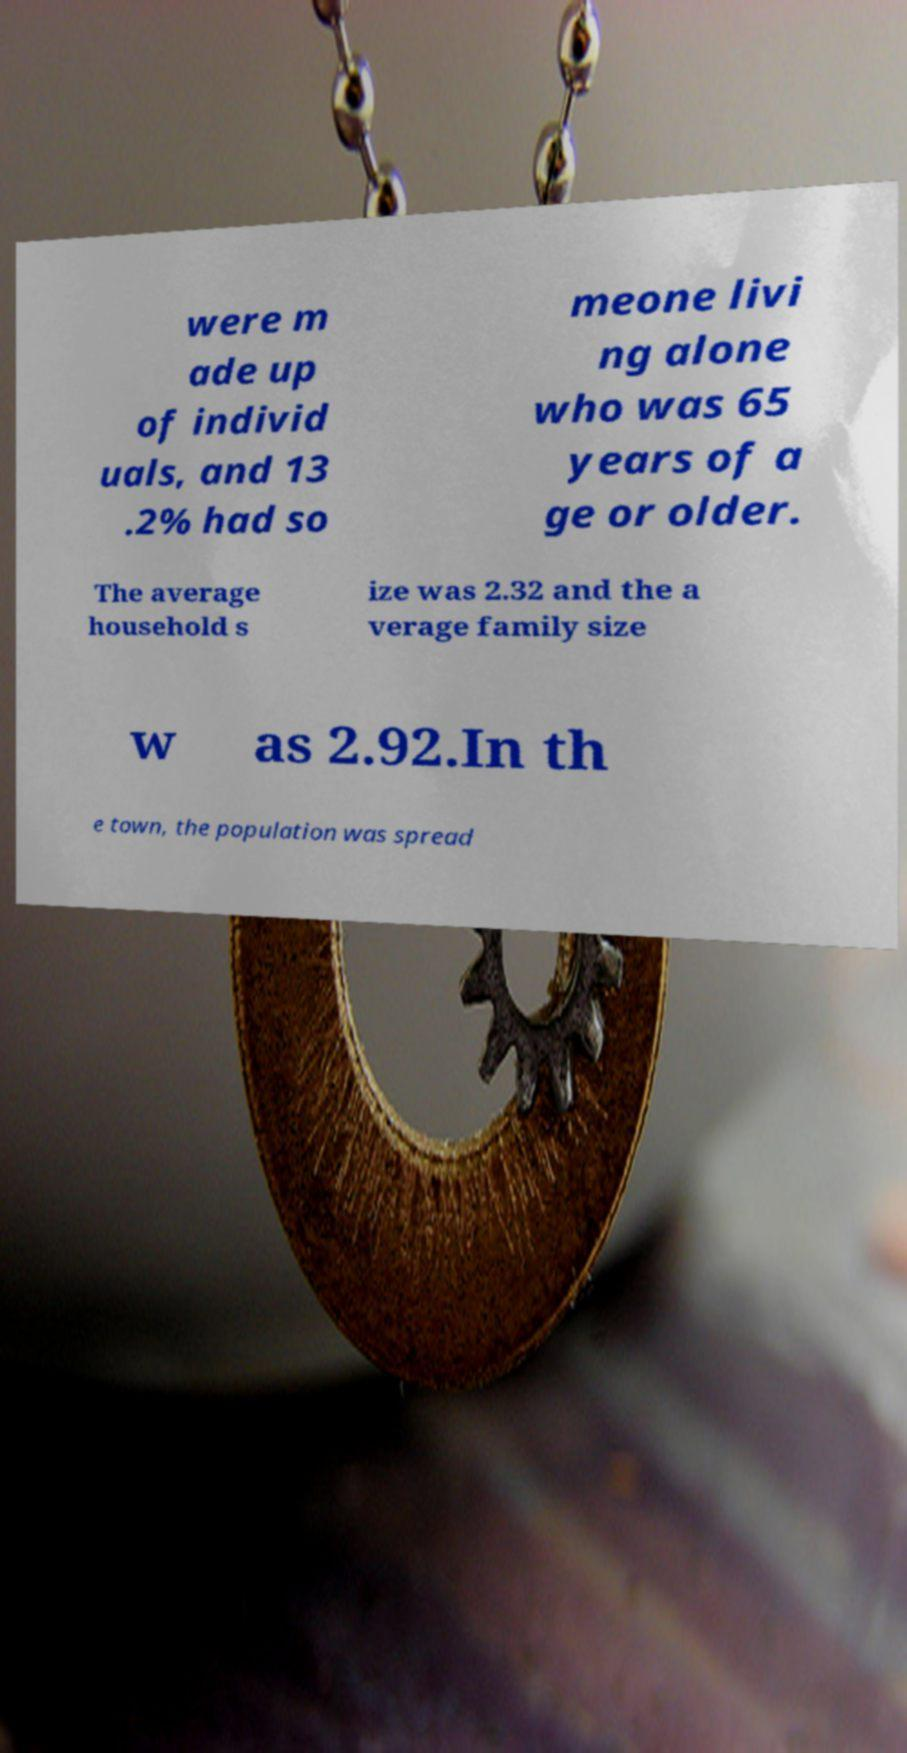Could you assist in decoding the text presented in this image and type it out clearly? were m ade up of individ uals, and 13 .2% had so meone livi ng alone who was 65 years of a ge or older. The average household s ize was 2.32 and the a verage family size w as 2.92.In th e town, the population was spread 